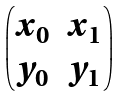<formula> <loc_0><loc_0><loc_500><loc_500>\begin{pmatrix} x _ { 0 } & x _ { 1 } \\ y _ { 0 } & y _ { 1 } \end{pmatrix}</formula> 